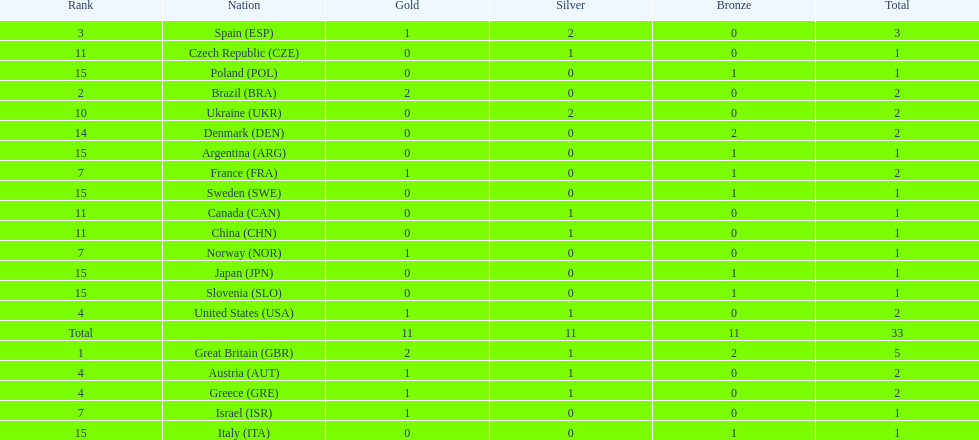How many gold medals did italy receive? 0. 